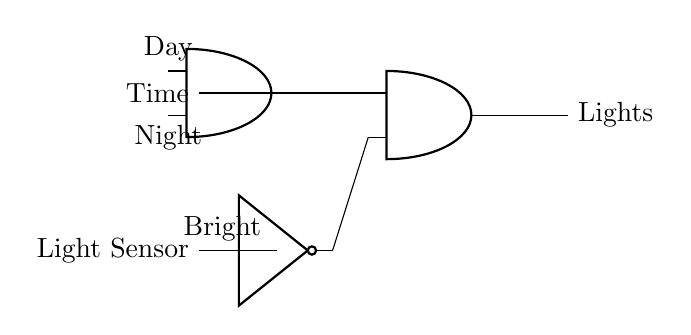What does the output control? The output controls the outdoor lights based on the inputs from the time and light sensor conditions.
Answer: Lights How many AND gates are in this circuit? There are two AND gates present in the circuit, one incorporating the time input and the other controlling the lights.
Answer: Two What condition enables the lights to turn on during the night? The lights will turn on during the night if the light sensor detects darkness (i.e., it is not bright). This means the NOT gate will output a high signal, enabling the AND gate's output when combined with the night input signal.
Answer: Night and not bright What is the role of the NOT gate in this circuit? The NOT gate inverts the signal from the light sensor; when it is bright, the output is low, which prevents the lights from being on. Therefore, it is active during darkness.
Answer: Inversion What are the inputs to the first AND gate? The first AND gate has two inputs: one from the time (day/night) signal and one from the light sensor signal after being processed by the NOT gate.
Answer: Time and processed light sensor 